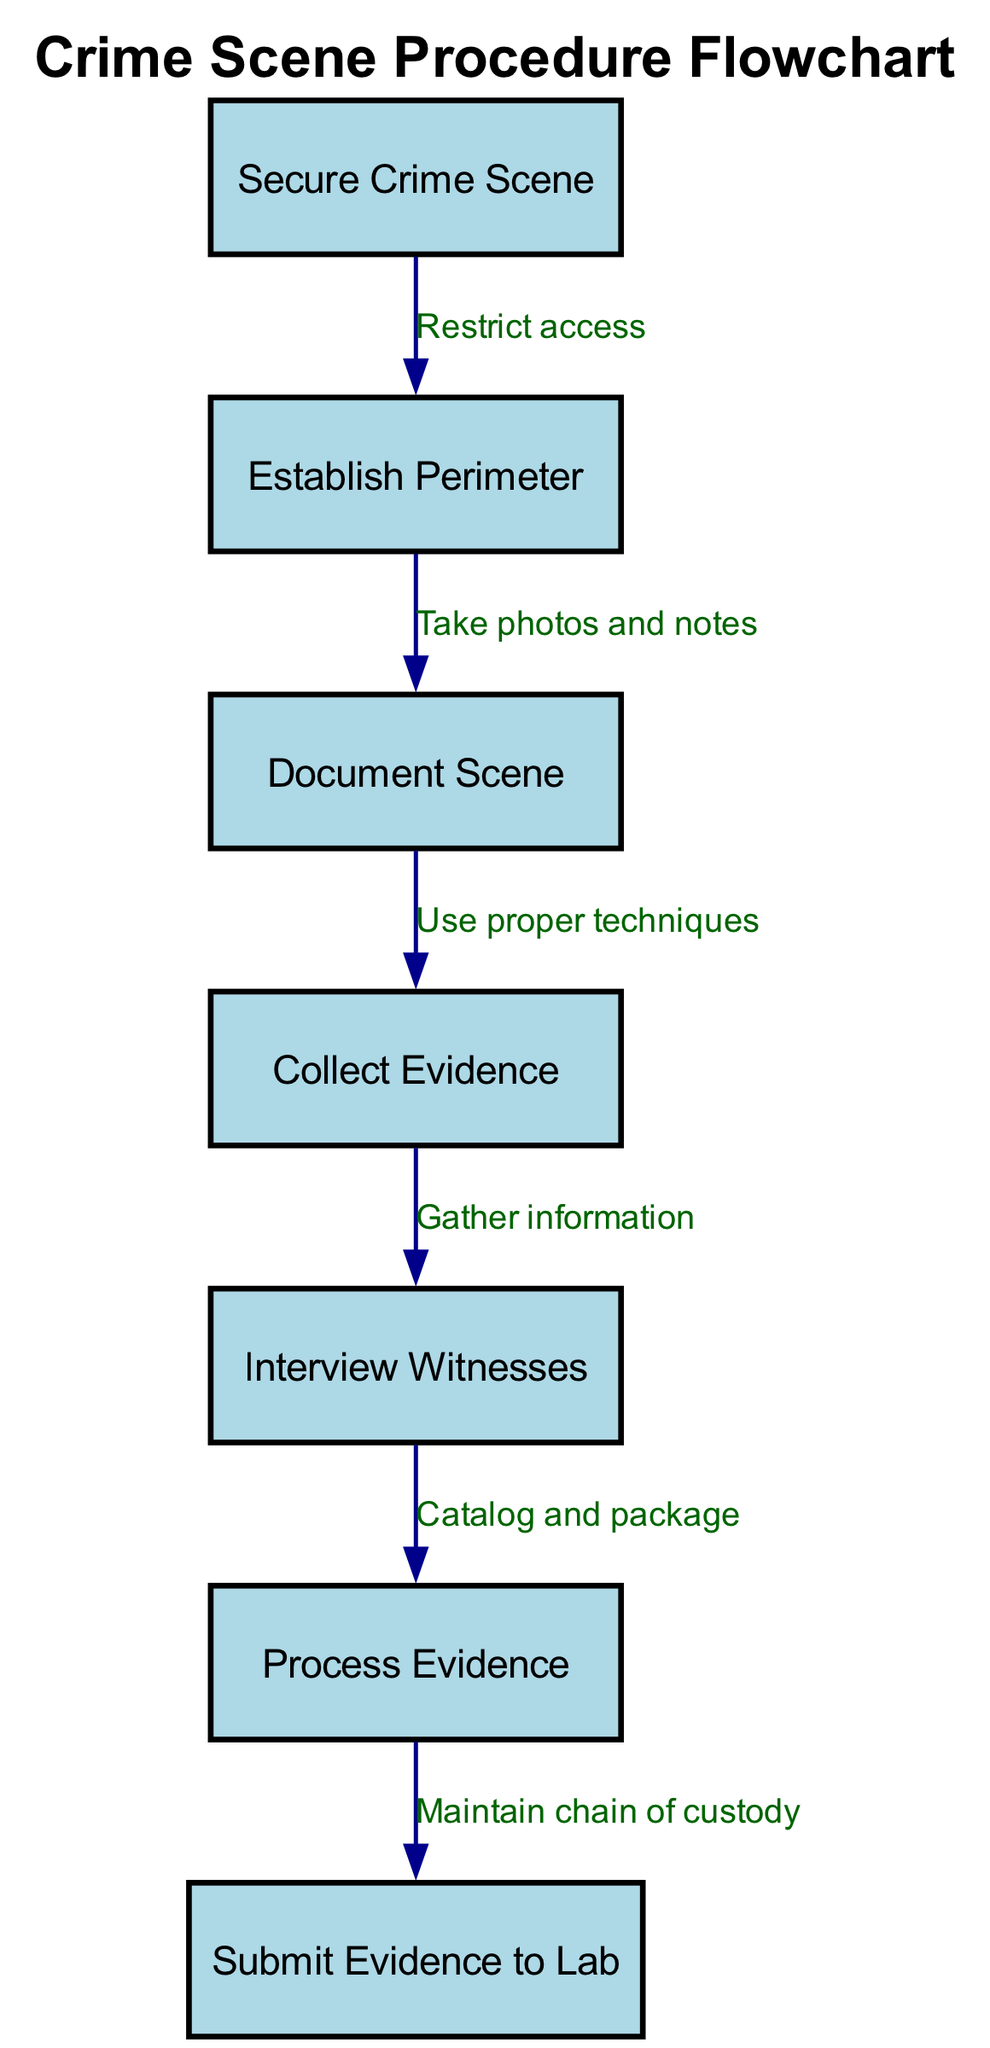What is the first step in the crime scene procedure? The flowchart indicates the first step is "Secure Crime Scene" which is the starting point of the process.
Answer: Secure Crime Scene How many nodes are present in the flowchart? The flowchart consists of a total of 7 nodes, each representing a specific step in the crime scene processing procedure.
Answer: 7 What action is taken after establishing the perimeter? According to the diagram, after establishing the perimeter, the next step is to "Document Scene", which involves taking photos and notes.
Answer: Document Scene Which step comes before collecting evidence? The diagram shows that "Document Scene" must be completed before moving on to collect evidence.
Answer: Document Scene What is required after processing evidence? According to the flowchart, after processing evidence, the next action is to "Submit Evidence to Lab" to continue the investigation process.
Answer: Submit Evidence to Lab What action follows the interview of witnesses? The flowchart indicates that after interviewing witnesses, the next step is to "Process Evidence", which involves cataloging and packaging.
Answer: Process Evidence What is the relationship between securing the crime scene and establishing the perimeter? The flowchart states that securing the crime scene involves restricting access, which leads to the establishment of a perimeter.
Answer: Restrict access How is evidence supposed to be handled after it is collected? The process requires that evidence is to be cataloged and packaged after it is collected to ensure proper handling and management.
Answer: Catalog and package 